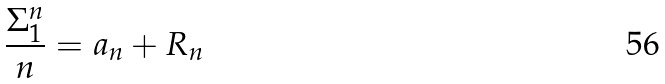Convert formula to latex. <formula><loc_0><loc_0><loc_500><loc_500>\frac { \Sigma _ { 1 } ^ { n } } { n } = a _ { n } + R _ { n }</formula> 